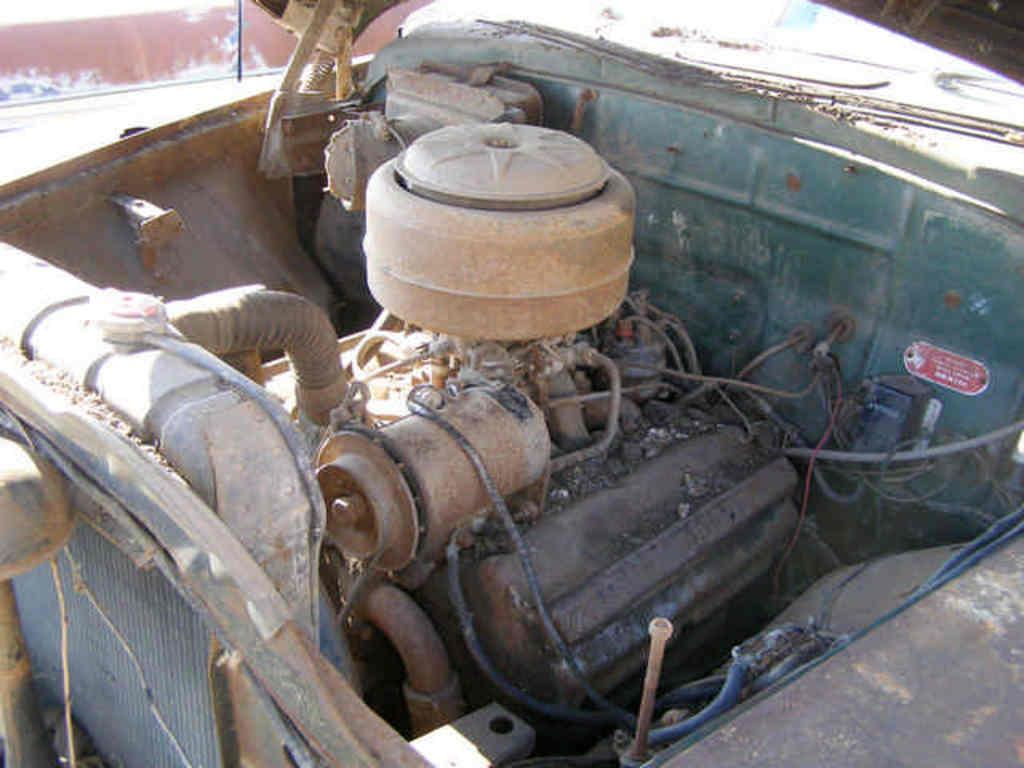What is the power source for the vehicle in the image? There is a motor in the vehicle. Where is the vehicle located in the image? The vehicle is on the road. What can be seen near the road in the image? There is a brown color wall near the road. What type of turkey can be seen roaming near the vehicle in the image? There is no turkey present in the image; it features a vehicle on the road and a brown color wall nearby. What achievements has the vehicle accomplished in the image? The vehicle is simply located on the road, and there is no indication of any achievements in the image. 